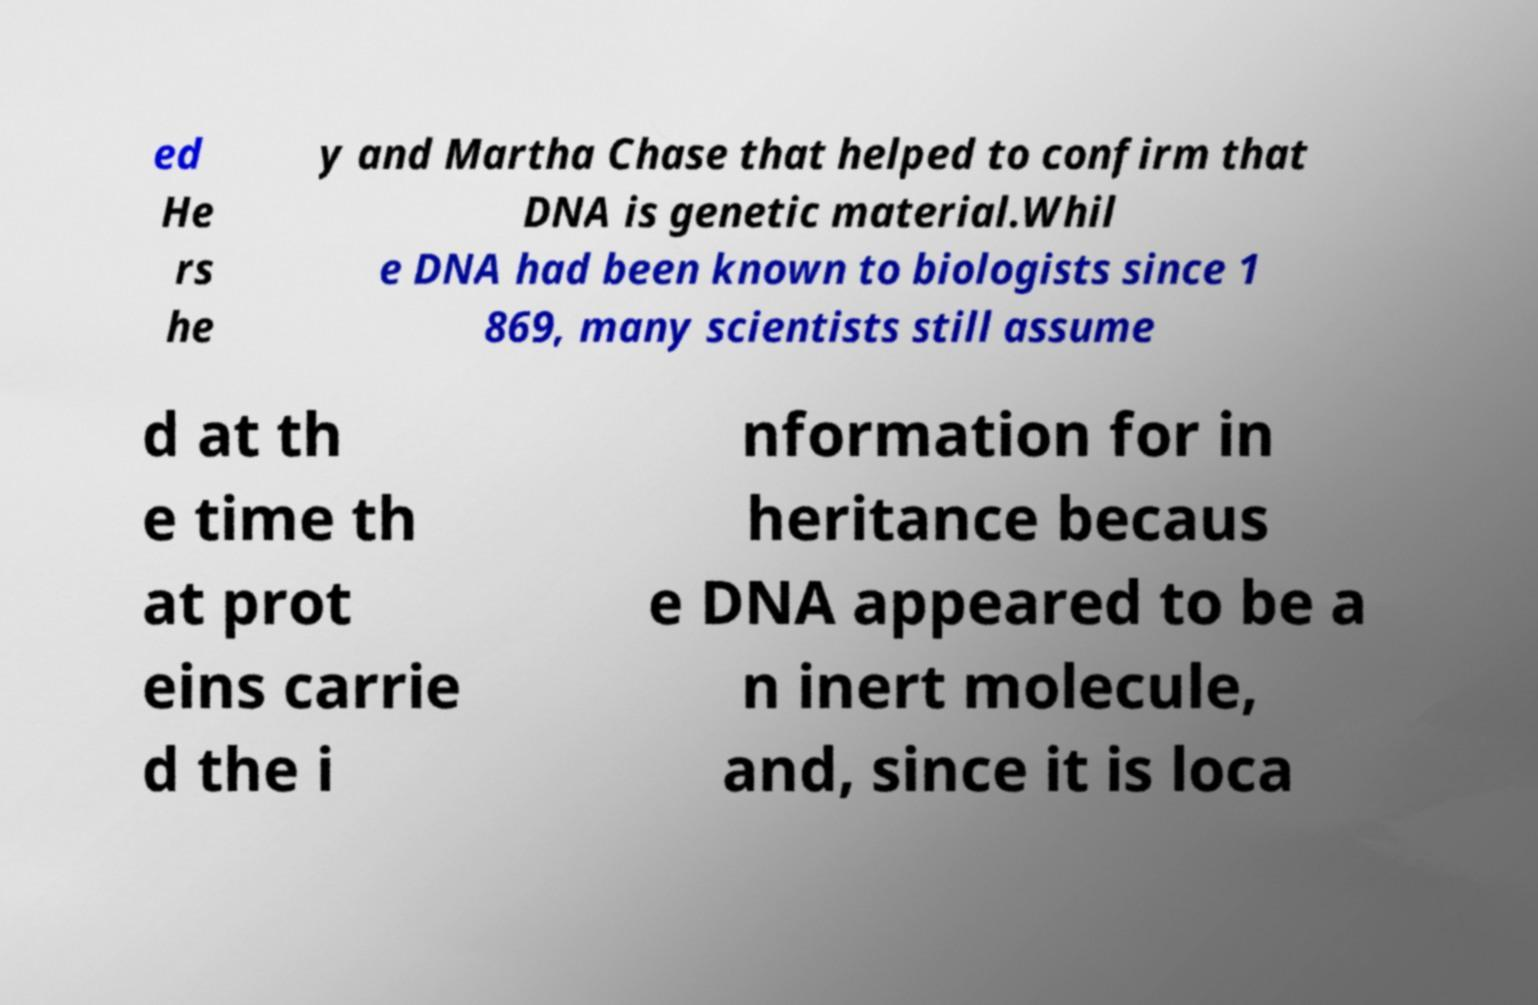There's text embedded in this image that I need extracted. Can you transcribe it verbatim? ed He rs he y and Martha Chase that helped to confirm that DNA is genetic material.Whil e DNA had been known to biologists since 1 869, many scientists still assume d at th e time th at prot eins carrie d the i nformation for in heritance becaus e DNA appeared to be a n inert molecule, and, since it is loca 